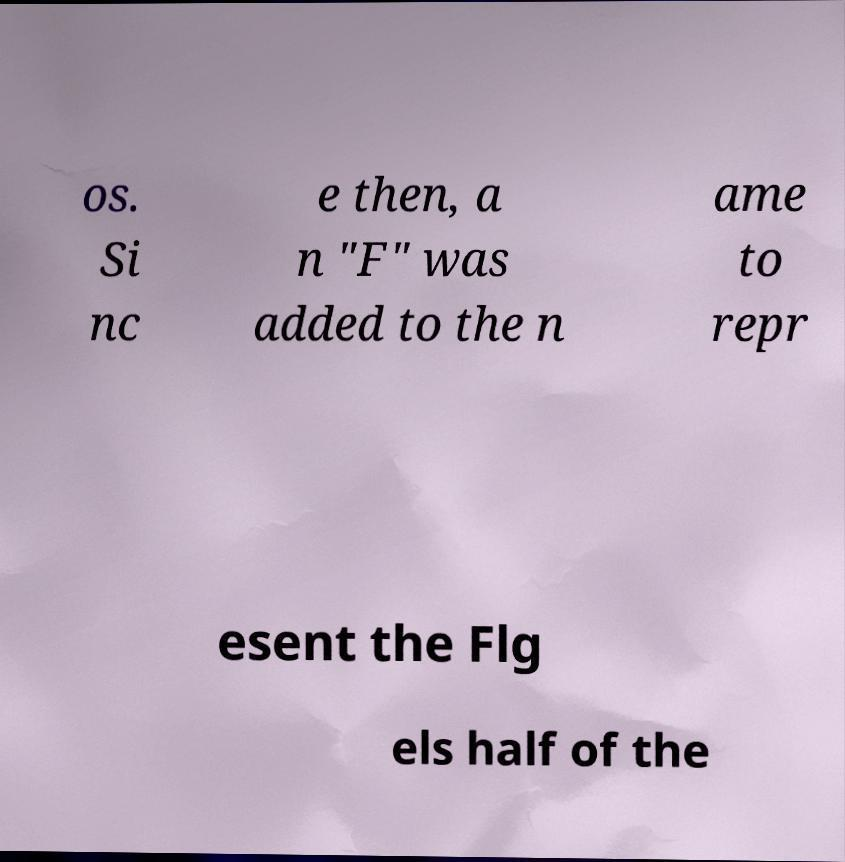For documentation purposes, I need the text within this image transcribed. Could you provide that? os. Si nc e then, a n "F" was added to the n ame to repr esent the Flg els half of the 